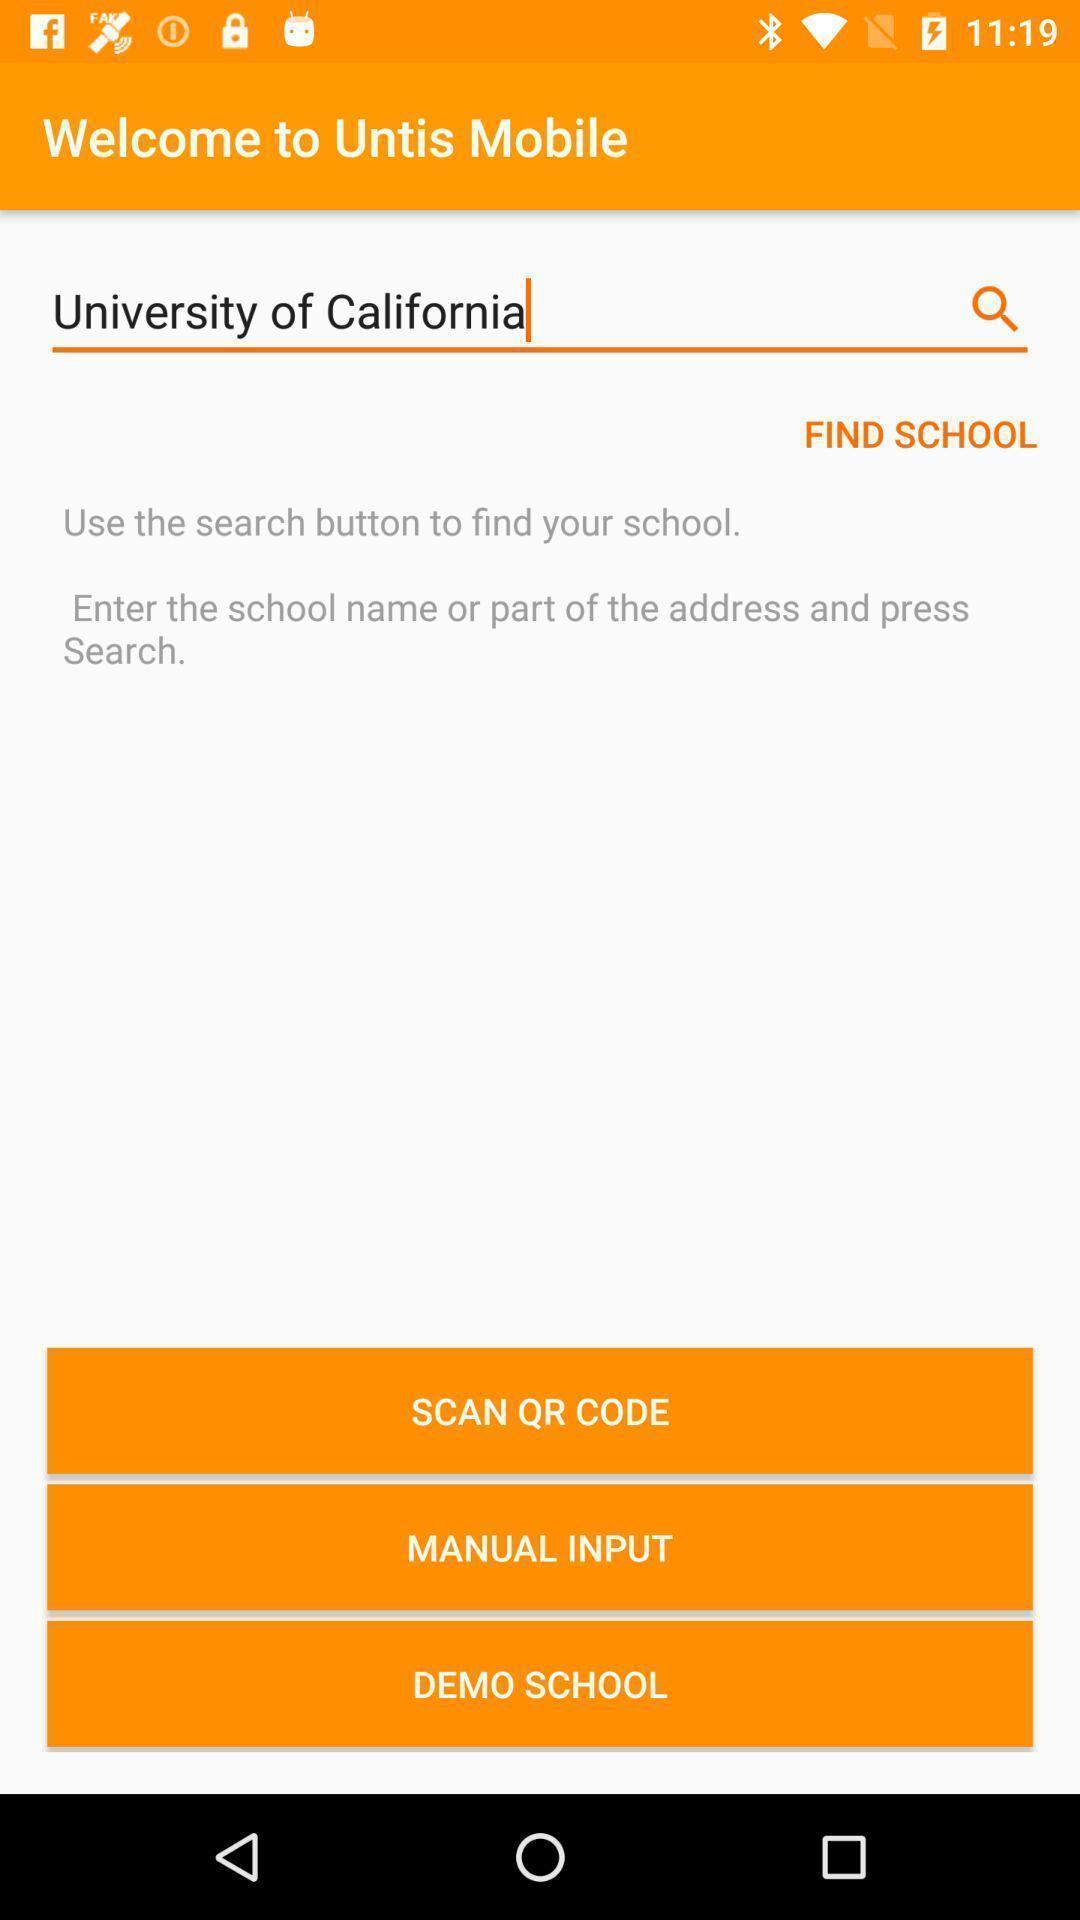Give me a summary of this screen capture. Welcome page. 